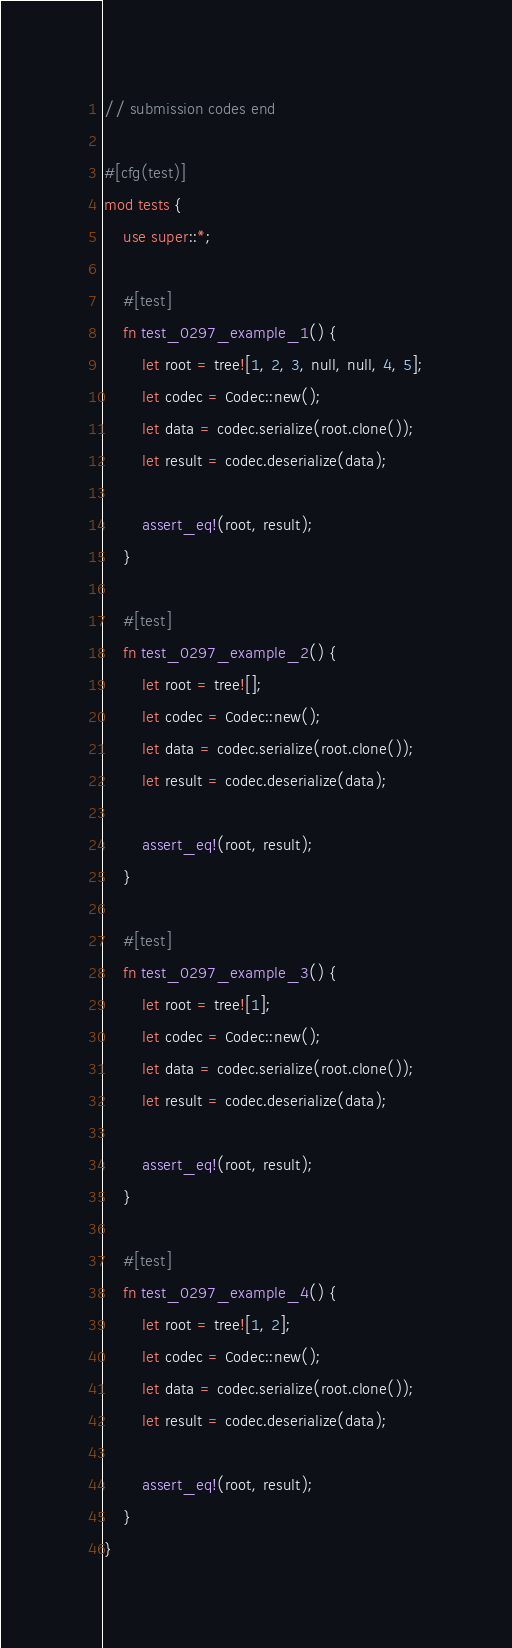Convert code to text. <code><loc_0><loc_0><loc_500><loc_500><_Rust_>// submission codes end

#[cfg(test)]
mod tests {
    use super::*;

    #[test]
    fn test_0297_example_1() {
        let root = tree![1, 2, 3, null, null, 4, 5];
        let codec = Codec::new();
        let data = codec.serialize(root.clone());
        let result = codec.deserialize(data);

        assert_eq!(root, result);
    }

    #[test]
    fn test_0297_example_2() {
        let root = tree![];
        let codec = Codec::new();
        let data = codec.serialize(root.clone());
        let result = codec.deserialize(data);

        assert_eq!(root, result);
    }

    #[test]
    fn test_0297_example_3() {
        let root = tree![1];
        let codec = Codec::new();
        let data = codec.serialize(root.clone());
        let result = codec.deserialize(data);

        assert_eq!(root, result);
    }

    #[test]
    fn test_0297_example_4() {
        let root = tree![1, 2];
        let codec = Codec::new();
        let data = codec.serialize(root.clone());
        let result = codec.deserialize(data);

        assert_eq!(root, result);
    }
}
</code> 